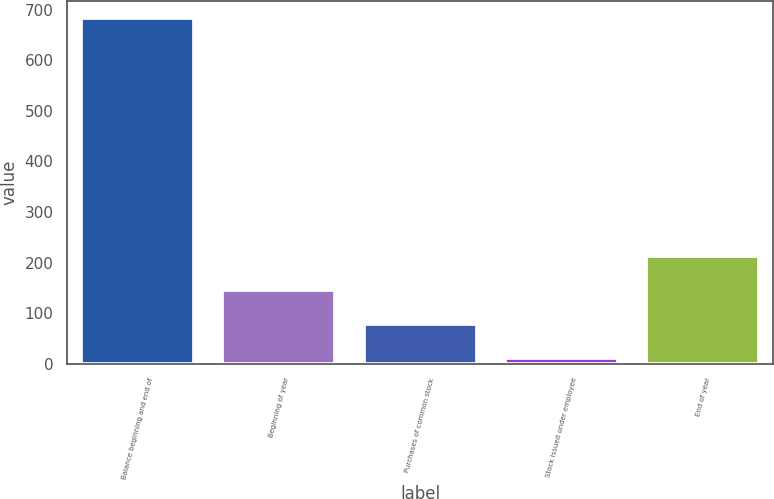Convert chart to OTSL. <chart><loc_0><loc_0><loc_500><loc_500><bar_chart><fcel>Balance beginning and end of<fcel>Beginning of year<fcel>Purchases of common stock<fcel>Stock issued under employee<fcel>End of year<nl><fcel>683<fcel>145.4<fcel>78.2<fcel>11<fcel>212.6<nl></chart> 